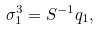<formula> <loc_0><loc_0><loc_500><loc_500>\sigma _ { 1 } ^ { 3 } = S ^ { - 1 } q _ { 1 } ,</formula> 